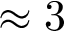Convert formula to latex. <formula><loc_0><loc_0><loc_500><loc_500>\approx 3</formula> 